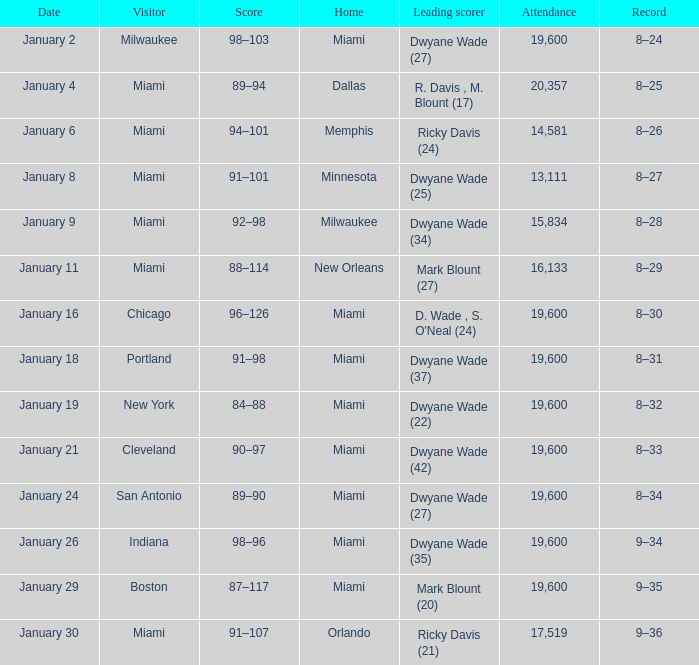Can you parse all the data within this table? {'header': ['Date', 'Visitor', 'Score', 'Home', 'Leading scorer', 'Attendance', 'Record'], 'rows': [['January 2', 'Milwaukee', '98–103', 'Miami', 'Dwyane Wade (27)', '19,600', '8–24'], ['January 4', 'Miami', '89–94', 'Dallas', 'R. Davis , M. Blount (17)', '20,357', '8–25'], ['January 6', 'Miami', '94–101', 'Memphis', 'Ricky Davis (24)', '14,581', '8–26'], ['January 8', 'Miami', '91–101', 'Minnesota', 'Dwyane Wade (25)', '13,111', '8–27'], ['January 9', 'Miami', '92–98', 'Milwaukee', 'Dwyane Wade (34)', '15,834', '8–28'], ['January 11', 'Miami', '88–114', 'New Orleans', 'Mark Blount (27)', '16,133', '8–29'], ['January 16', 'Chicago', '96–126', 'Miami', "D. Wade , S. O'Neal (24)", '19,600', '8–30'], ['January 18', 'Portland', '91–98', 'Miami', 'Dwyane Wade (37)', '19,600', '8–31'], ['January 19', 'New York', '84–88', 'Miami', 'Dwyane Wade (22)', '19,600', '8–32'], ['January 21', 'Cleveland', '90–97', 'Miami', 'Dwyane Wade (42)', '19,600', '8–33'], ['January 24', 'San Antonio', '89–90', 'Miami', 'Dwyane Wade (27)', '19,600', '8–34'], ['January 26', 'Indiana', '98–96', 'Miami', 'Dwyane Wade (35)', '19,600', '9–34'], ['January 29', 'Boston', '87–117', 'Miami', 'Mark Blount (20)', '19,600', '9–35'], ['January 30', 'Miami', '91–107', 'Orlando', 'Ricky Davis (21)', '17,519', '9–36']]} What date were there more than 19,600 people in attendance? January 4. 